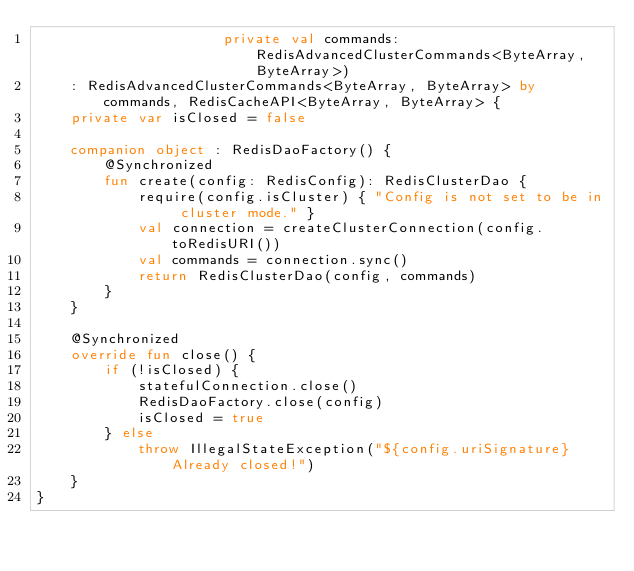Convert code to text. <code><loc_0><loc_0><loc_500><loc_500><_Kotlin_>                      private val commands: RedisAdvancedClusterCommands<ByteArray, ByteArray>)
    : RedisAdvancedClusterCommands<ByteArray, ByteArray> by commands, RedisCacheAPI<ByteArray, ByteArray> {
    private var isClosed = false

    companion object : RedisDaoFactory() {
        @Synchronized
        fun create(config: RedisConfig): RedisClusterDao {
            require(config.isCluster) { "Config is not set to be in cluster mode." }
            val connection = createClusterConnection(config.toRedisURI())
            val commands = connection.sync()
            return RedisClusterDao(config, commands)
        }
    }

    @Synchronized
    override fun close() {
        if (!isClosed) {
            statefulConnection.close()
            RedisDaoFactory.close(config)
            isClosed = true
        } else
            throw IllegalStateException("${config.uriSignature} Already closed!")
    }
}</code> 